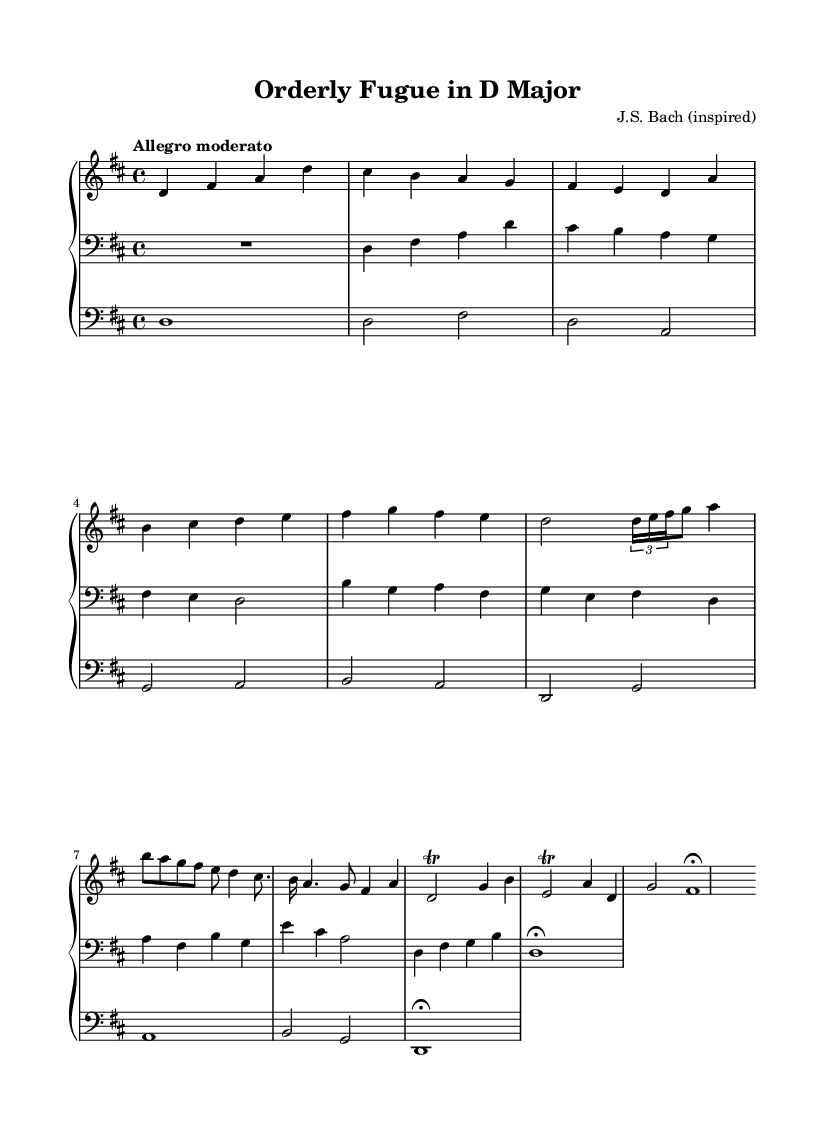What is the key signature of this music? The key signature is indicated by the two sharps present on the staff, representing F# and C#. This aligns with D major, where the key signature includes these two sharps.
Answer: D major What is the time signature of this music? The time signature appears at the beginning of the piece, specified as 4/4, indicating that there are four beats in each measure and the quarter note receives one beat.
Answer: 4/4 What is the tempo marking for this composition? The tempo marking is indicated above the staff as "Allegro moderato," which suggests a moderately fast pace for the performance of this piece.
Answer: Allegro moderato How many measures are there in the exposition section? The exposition consists of four measures in the right hand and three measures in the left hand, totaling seven measures overall.
Answer: Seven measures Which musical form is primarily used in this composition? The structure of the composition follows the form characterized by an Exposition, Development, and Recapitulation, which is typical in the genre of fugues and similar Baroque compositions.
Answer: Fugue What is the dynamic marking in the recapitulation section? There are no specific dynamic markings provided in the sheet music; thus, dynamics can be interpreted by the performer for expressive purposes as is common in Baroque music.
Answer: None specified How is the pedal part utilized in this composition? The pedal part supports the harmonic foundation by playing root notes and contributing to the overall sonority when combined with the other two staffs, typical of Baroque organ music.
Answer: Harmonic foundation 